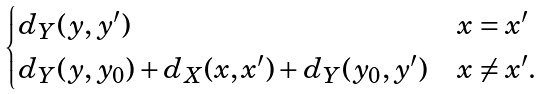<formula> <loc_0><loc_0><loc_500><loc_500>\begin{cases} d _ { Y } ( y , y ^ { \prime } ) & x = x ^ { \prime } \\ d _ { Y } ( y , y _ { 0 } ) + d _ { X } ( x , x ^ { \prime } ) + d _ { Y } ( y _ { 0 } , y ^ { \prime } ) & x \neq x ^ { \prime } . \end{cases}</formula> 